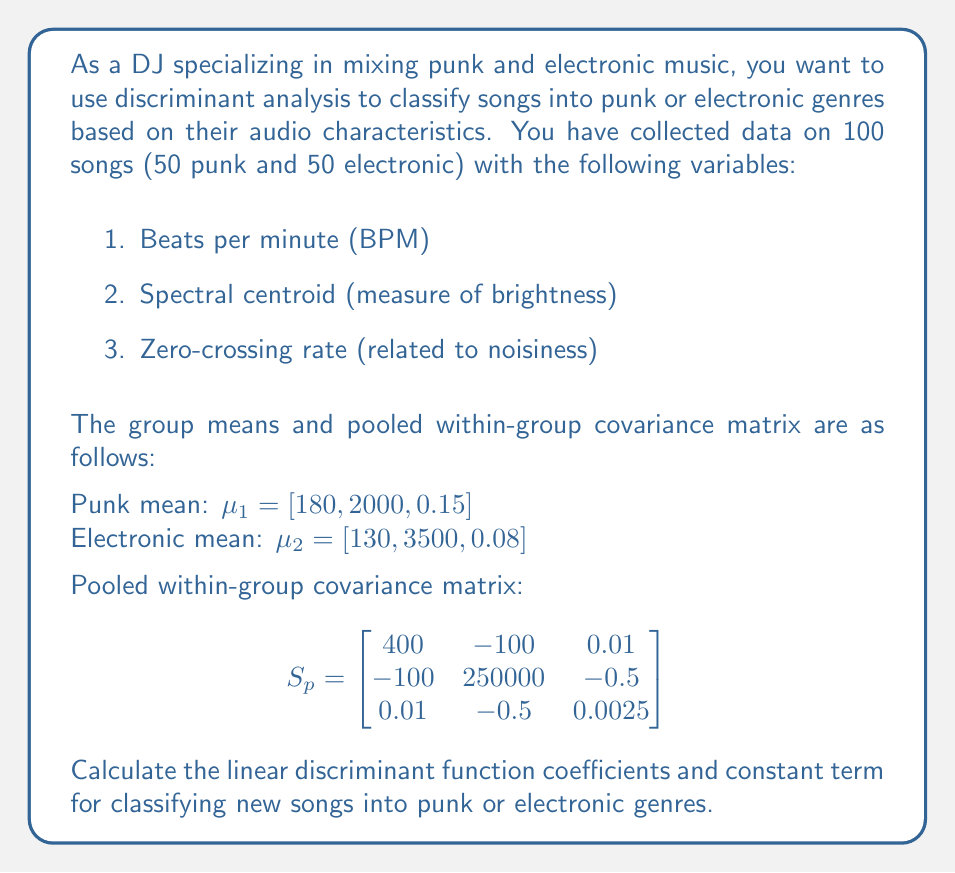What is the answer to this math problem? To solve this problem, we'll follow these steps:

1. Calculate the difference between group means
2. Calculate the inverse of the pooled within-group covariance matrix
3. Compute the linear discriminant function coefficients
4. Calculate the constant term

Step 1: Calculate the difference between group means
$\Delta\mu = \mu_1 - \mu_2 = [180, 2000, 0.15] - [130, 3500, 0.08] = [50, -1500, 0.07]$

Step 2: Calculate the inverse of the pooled within-group covariance matrix
We need to find $S_p^{-1}$. Using a calculator or computer algebra system, we get:

$$S_p^{-1} = \begin{bmatrix}
0.002532 & 0.000001 & -0.010127 \\
0.000001 & 0.000004 & 0.000800 \\
-0.010127 & 0.000800 & 400.320508
\end{bmatrix}$$

Step 3: Compute the linear discriminant function coefficients
The linear discriminant function coefficients are given by:

$a = S_p^{-1} \Delta\mu$

Multiplying the inverse covariance matrix by the mean difference vector:

$$a = \begin{bmatrix}
0.002532 & 0.000001 & -0.010127 \\
0.000001 & 0.000004 & 0.000800 \\
-0.010127 & 0.000800 & 400.320508
\end{bmatrix} \begin{bmatrix}
50 \\
-1500 \\
0.07
\end{bmatrix}$$

Calculating this multiplication:

$a = [0.126169, -0.005994, 27.988435]$

Step 4: Calculate the constant term
The constant term is given by:

$c = -\frac{1}{2}(\mu_1 + \mu_2)a^T$

First, calculate the average of the means:
$\frac{1}{2}(\mu_1 + \mu_2) = [155, 2750, 0.115]$

Then, multiply by $a^T$ and negate:

$c = -([155, 2750, 0.115] \cdot [0.126169, -0.005994, 27.988435])$

$c = -([19.556195 - 16.4835 + 3.218670])$

$c = -6.291365$

The linear discriminant function is then:

$f(x) = 0.126169x_1 - 0.005994x_2 + 27.988435x_3 - 6.291365$

Where $x_1$ is BPM, $x_2$ is spectral centroid, and $x_3$ is zero-crossing rate.
Answer: Linear discriminant function coefficients: $a = [0.126169, -0.005994, 27.988435]$
Constant term: $c = -6.291365$ 